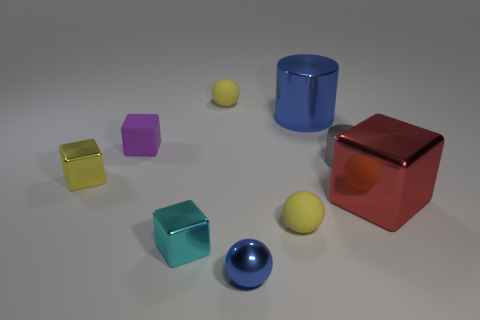What number of metallic things have the same size as the blue metallic ball?
Offer a very short reply. 3. There is a cube that is on the left side of the purple object; is it the same color as the big object that is behind the large red cube?
Make the answer very short. No. Are there any small blue shiny balls behind the big blue cylinder?
Give a very brief answer. No. The ball that is in front of the tiny yellow block and behind the tiny blue sphere is what color?
Your answer should be compact. Yellow. Is there a large metal cube of the same color as the tiny shiny cylinder?
Provide a succinct answer. No. Are the yellow sphere that is in front of the blue metal cylinder and the small ball left of the metallic sphere made of the same material?
Keep it short and to the point. Yes. There is a matte object that is in front of the yellow cube; how big is it?
Your answer should be compact. Small. What size is the cyan cube?
Provide a short and direct response. Small. What size is the thing that is behind the blue object right of the yellow rubber ball in front of the red cube?
Provide a short and direct response. Small. Are there any yellow balls that have the same material as the tiny blue thing?
Ensure brevity in your answer.  No. 